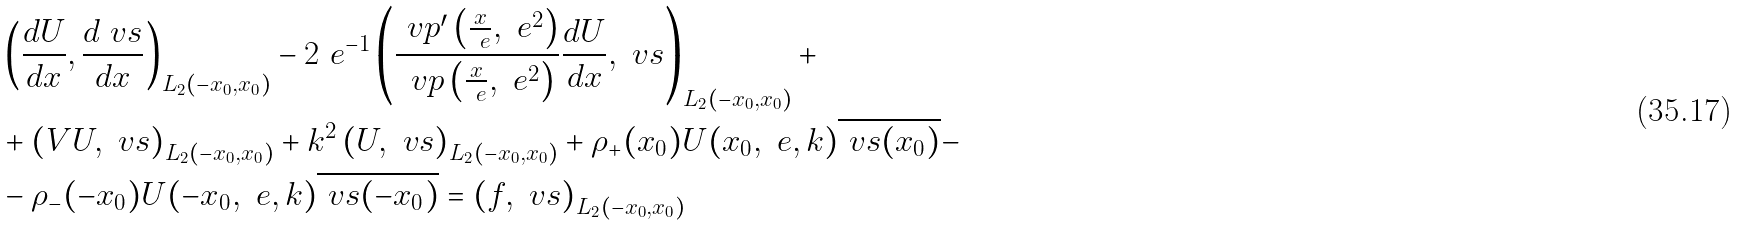Convert formula to latex. <formula><loc_0><loc_0><loc_500><loc_500>& \left ( \frac { d U } { d x } , \frac { d \ v s } { d x } \right ) _ { L _ { 2 } ( - x _ { 0 } , x _ { 0 } ) } - 2 \ e ^ { - 1 } \left ( \frac { \ v p ^ { \prime } \left ( \frac { x } { \ e } , \ e ^ { 2 } \right ) } { { \ v p } \left ( \frac { x } { \ e } , \ e ^ { 2 } \right ) } \frac { d U } { d x } , \ v s \right ) _ { L _ { 2 } ( - x _ { 0 } , x _ { 0 } ) } + \\ & + \left ( V U , \ v s \right ) _ { L _ { 2 } ( - x _ { 0 } , x _ { 0 } ) } + k ^ { 2 } \left ( U , \ v s \right ) _ { L _ { 2 } ( - x _ { 0 } , x _ { 0 } ) } + \rho _ { + } ( x _ { 0 } ) U ( x _ { 0 } , \ e , k ) \overline { \ v s ( x _ { 0 } ) } - \\ & - \rho _ { - } ( - x _ { 0 } ) U ( - x _ { 0 } , \ e , k ) \overline { \ v s ( - x _ { 0 } ) } = \left ( f , \ v s \right ) _ { L _ { 2 } ( - x _ { 0 } , x _ { 0 } ) }</formula> 